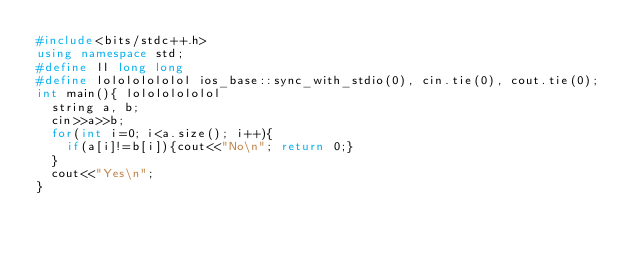<code> <loc_0><loc_0><loc_500><loc_500><_C++_>#include<bits/stdc++.h>
using namespace std;
#define ll long long
#define lolololololol ios_base::sync_with_stdio(0), cin.tie(0), cout.tie(0);
int main(){ lolololololol
	string a, b;
	cin>>a>>b;
	for(int i=0; i<a.size(); i++){
		if(a[i]!=b[i]){cout<<"No\n"; return 0;}
	}
	cout<<"Yes\n";
}</code> 